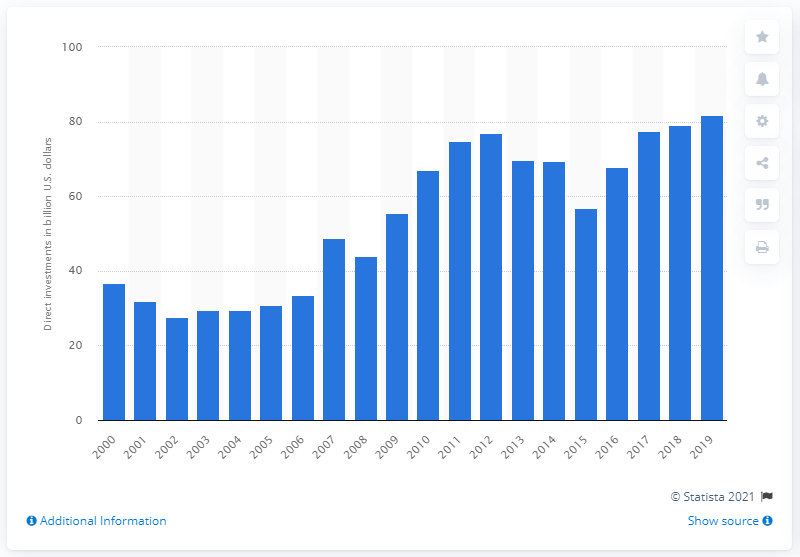Mention a couple of crucial points in this snapshot. In 2019, a total of 81.73 dollars were invested in Brazil. 